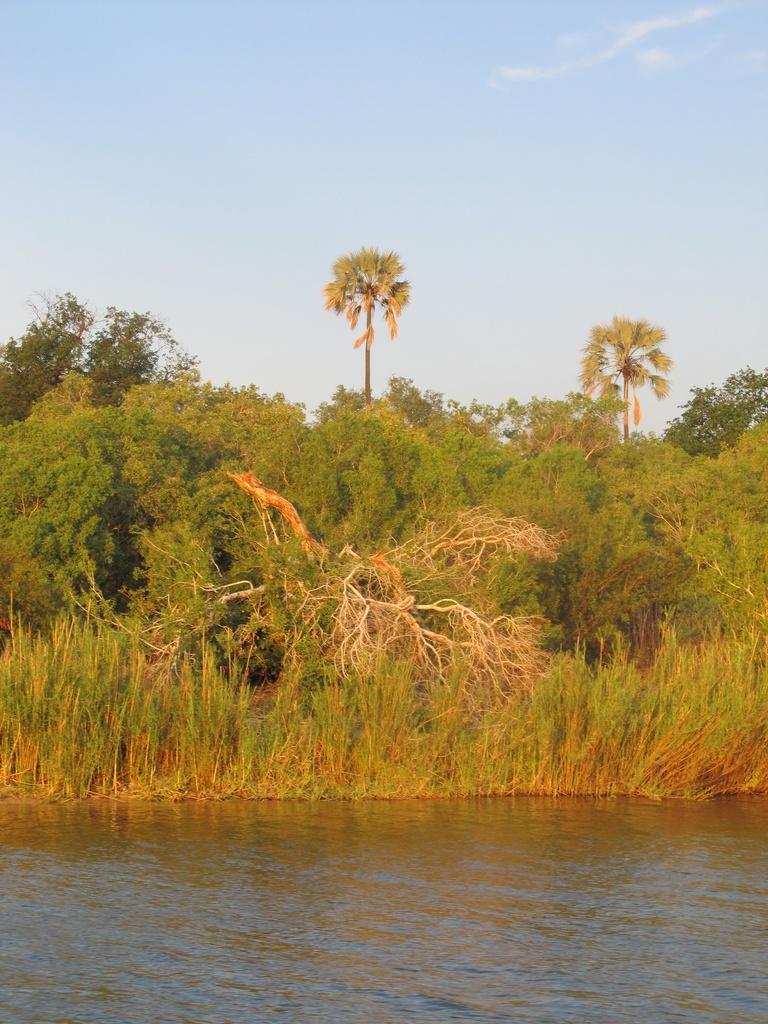In one or two sentences, can you explain what this image depicts? In this picture I can see some water, side there are some plants and trees. 